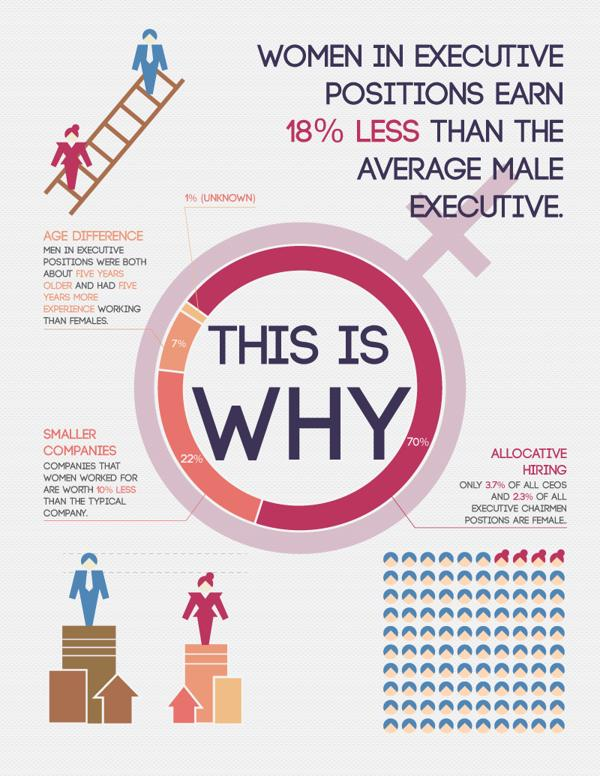Outline some significant characteristics in this image. The color of the male executive's suit is blue, not pink. The salary of an average male executive is 18% higher than that of a female executive. 63% of all CEOs are male. It is estimated that approximately 77% of all executive chairman positions are held by males. In executive positions, men were more frequently found to be older and more experienced than women, indicating gender bias in the workplace. 